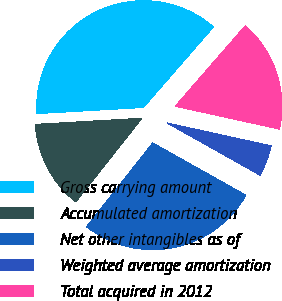Convert chart. <chart><loc_0><loc_0><loc_500><loc_500><pie_chart><fcel>Gross carrying amount<fcel>Accumulated amortization<fcel>Net other intangibles as of<fcel>Weighted average amortization<fcel>Total acquired in 2012<nl><fcel>37.31%<fcel>13.43%<fcel>27.5%<fcel>4.7%<fcel>17.05%<nl></chart> 